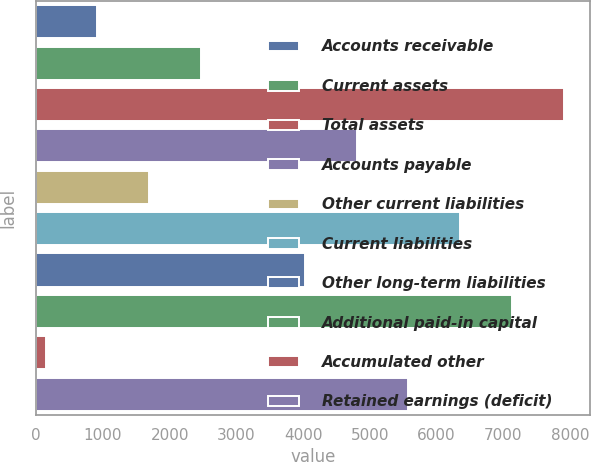Convert chart. <chart><loc_0><loc_0><loc_500><loc_500><bar_chart><fcel>Accounts receivable<fcel>Current assets<fcel>Total assets<fcel>Accounts payable<fcel>Other current liabilities<fcel>Current liabilities<fcel>Other long-term liabilities<fcel>Additional paid-in capital<fcel>Accumulated other<fcel>Retained earnings (deficit)<nl><fcel>914.8<fcel>2468.4<fcel>7906<fcel>4798.8<fcel>1691.6<fcel>6352.4<fcel>4022<fcel>7129.2<fcel>138<fcel>5575.6<nl></chart> 